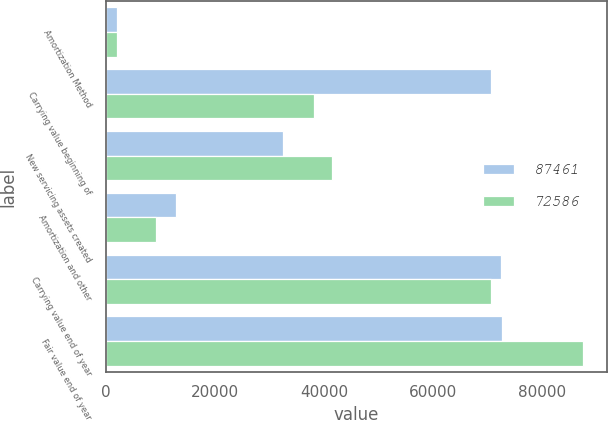Convert chart. <chart><loc_0><loc_0><loc_500><loc_500><stacked_bar_chart><ecel><fcel>Amortization Method<fcel>Carrying value beginning of<fcel>New servicing assets created<fcel>Amortization and other<fcel>Carrying value end of year<fcel>Fair value end of year<nl><fcel>87461<fcel>2011<fcel>70516<fcel>32505<fcel>12938<fcel>72434<fcel>72586<nl><fcel>72586<fcel>2010<fcel>38165<fcel>41489<fcel>9138<fcel>70516<fcel>87461<nl></chart> 